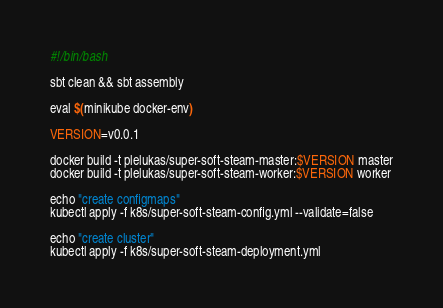Convert code to text. <code><loc_0><loc_0><loc_500><loc_500><_Bash_>#!/bin/bash

sbt clean && sbt assembly

eval $(minikube docker-env)

VERSION=v0.0.1

docker build -t plelukas/super-soft-steam-master:$VERSION master
docker build -t plelukas/super-soft-steam-worker:$VERSION worker

echo "create configmaps"
kubectl apply -f k8s/super-soft-steam-config.yml --validate=false

echo "create cluster"
kubectl apply -f k8s/super-soft-steam-deployment.yml
</code> 